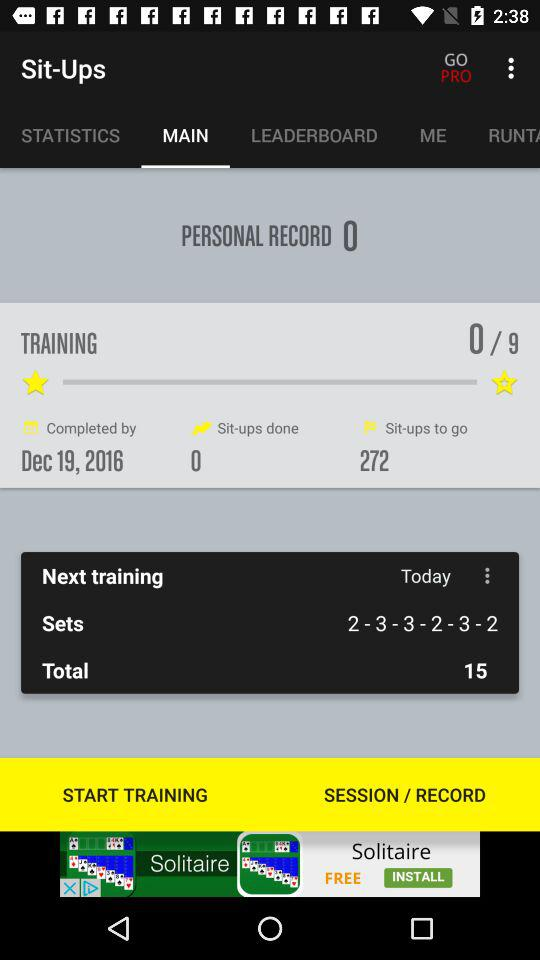On what date was the training completed? The training was completed on 19th December, 2016. 